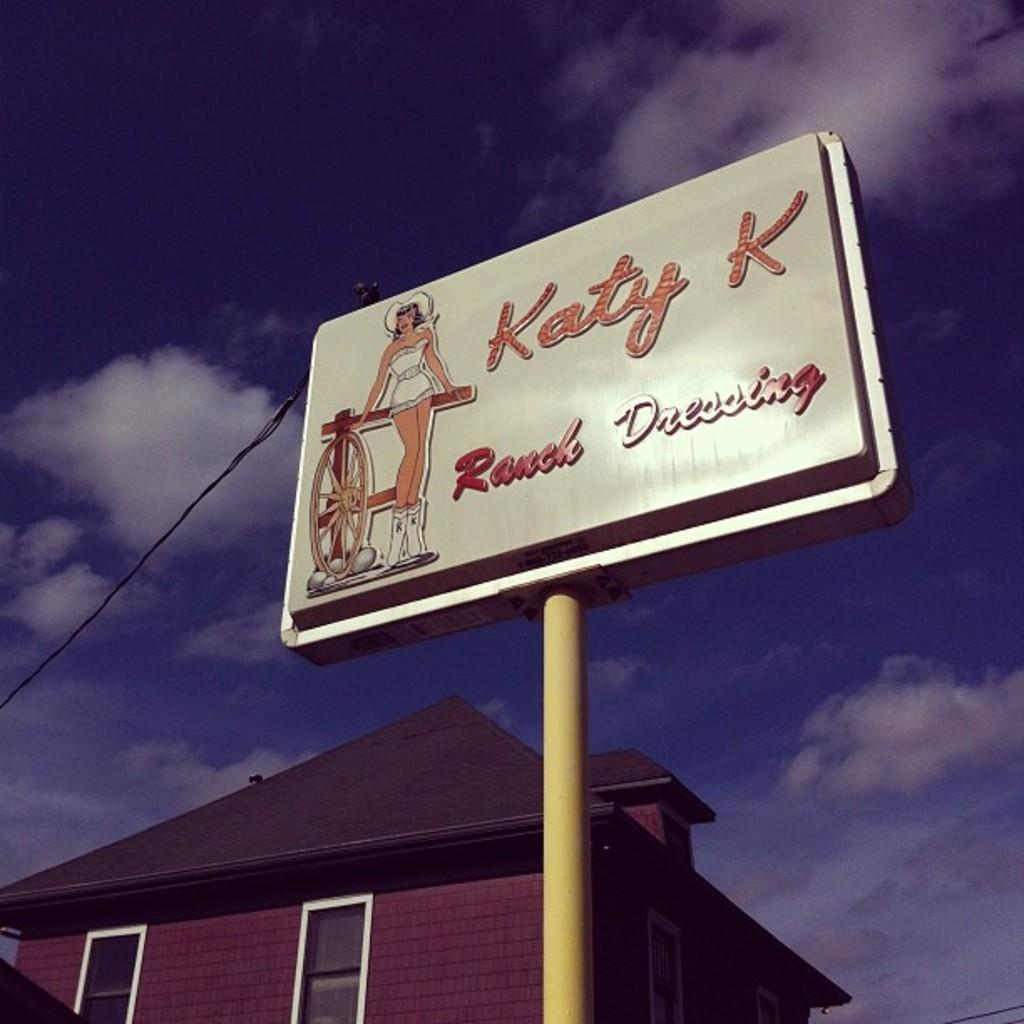<image>
Write a terse but informative summary of the picture. A sign with a cowgirl on it advertises Katy K Ranch Dressing. 